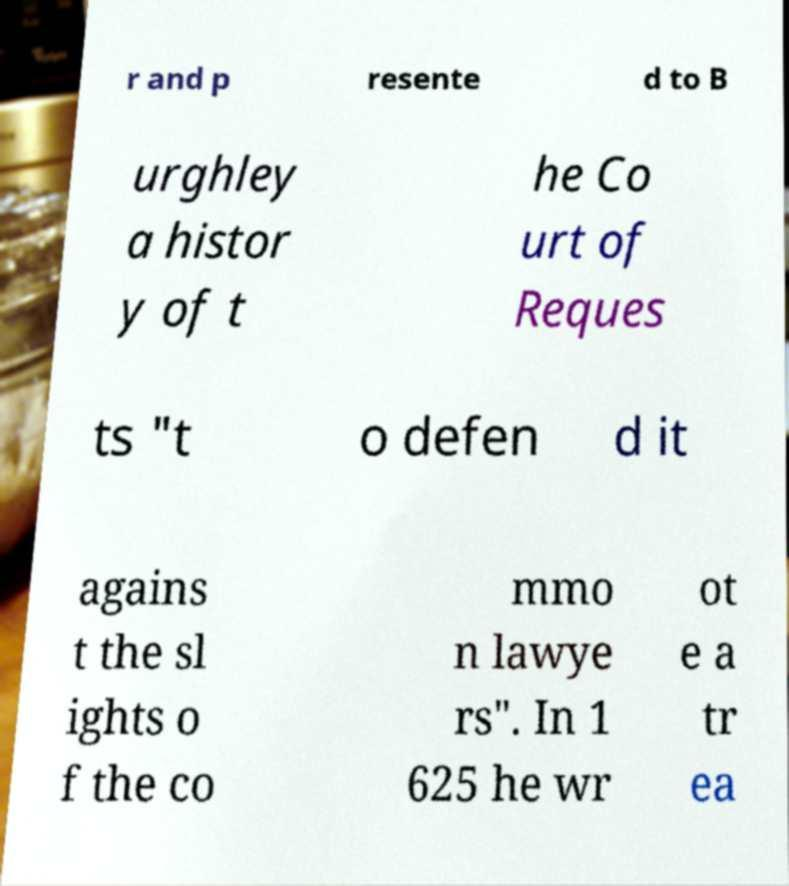Can you read and provide the text displayed in the image?This photo seems to have some interesting text. Can you extract and type it out for me? r and p resente d to B urghley a histor y of t he Co urt of Reques ts "t o defen d it agains t the sl ights o f the co mmo n lawye rs". In 1 625 he wr ot e a tr ea 